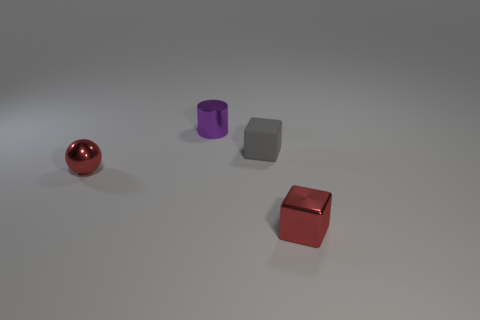Add 1 small objects. How many objects exist? 5 Subtract all gray blocks. How many blocks are left? 1 Subtract all cylinders. How many objects are left? 3 Add 3 small gray things. How many small gray things are left? 4 Add 2 spheres. How many spheres exist? 3 Subtract 0 green spheres. How many objects are left? 4 Subtract all yellow cubes. Subtract all cyan spheres. How many cubes are left? 2 Subtract all small cyan matte blocks. Subtract all tiny metal cubes. How many objects are left? 3 